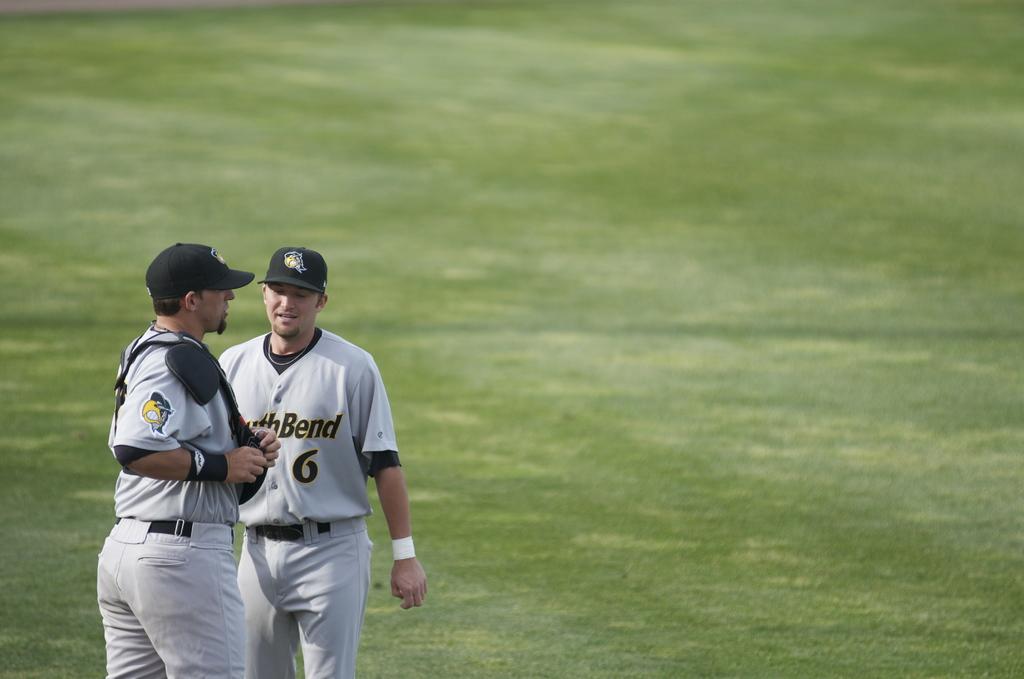What number is the player without the chest guard?
Keep it short and to the point. 6. 